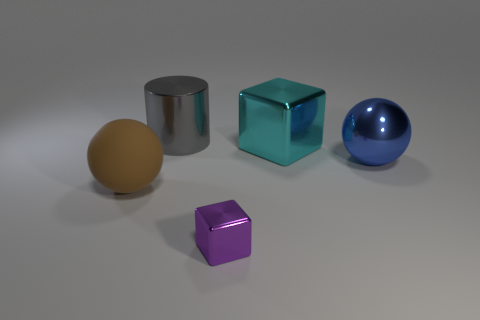The cube that is behind the brown matte ball is what color?
Provide a short and direct response. Cyan. There is a big cyan thing that is made of the same material as the tiny cube; what is its shape?
Your answer should be very brief. Cube. Is there any other thing that has the same color as the small shiny thing?
Offer a very short reply. No. Is the number of big gray metallic cylinders behind the metal sphere greater than the number of big blue things left of the large cylinder?
Provide a short and direct response. Yes. What number of cyan things have the same size as the brown matte sphere?
Offer a very short reply. 1. Are there fewer big gray shiny objects that are right of the large gray object than purple metal things that are behind the cyan metallic thing?
Offer a very short reply. No. Are there any large blue metal objects that have the same shape as the big gray thing?
Your answer should be compact. No. Does the large blue shiny thing have the same shape as the large cyan object?
Your response must be concise. No. How many small objects are either brown balls or blue spheres?
Give a very brief answer. 0. Is the number of tiny brown metal things greater than the number of small purple shiny cubes?
Your response must be concise. No. 